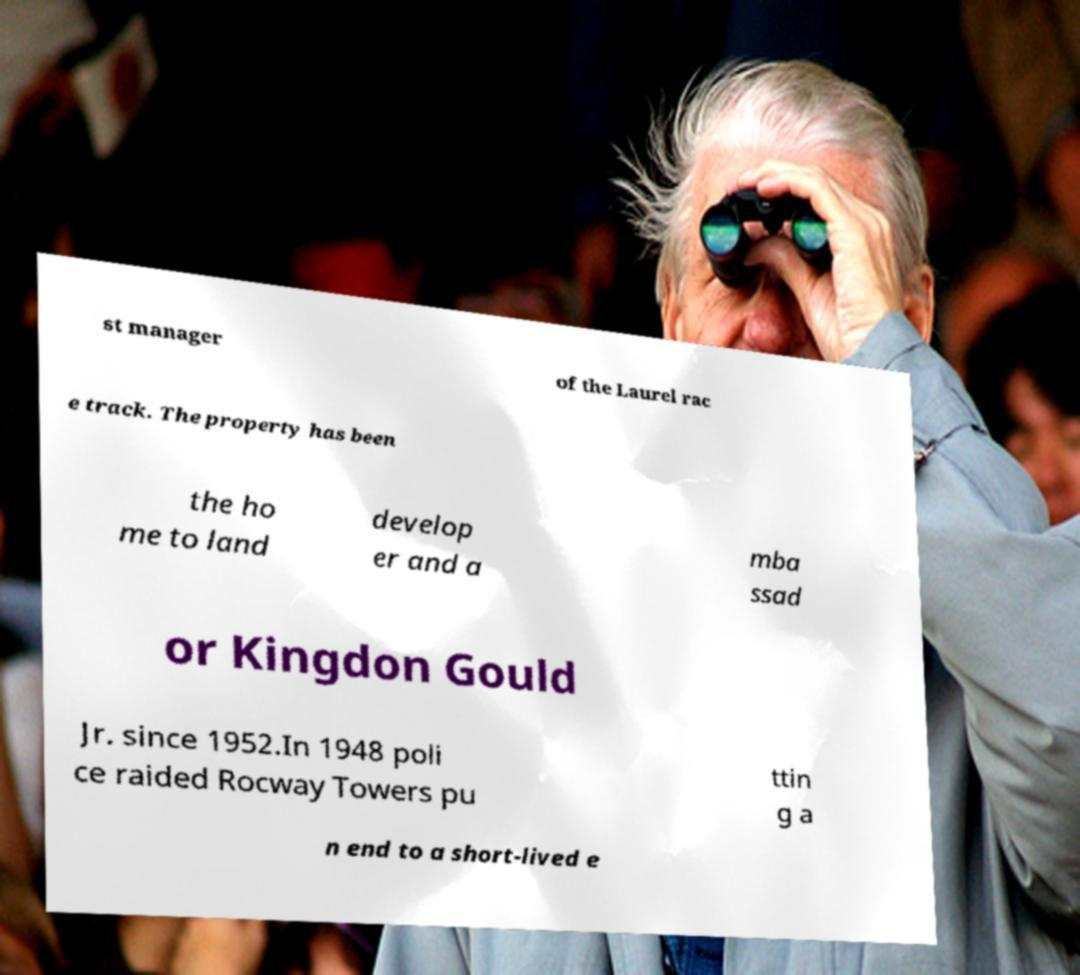Can you accurately transcribe the text from the provided image for me? st manager of the Laurel rac e track. The property has been the ho me to land develop er and a mba ssad or Kingdon Gould Jr. since 1952.In 1948 poli ce raided Rocway Towers pu ttin g a n end to a short-lived e 